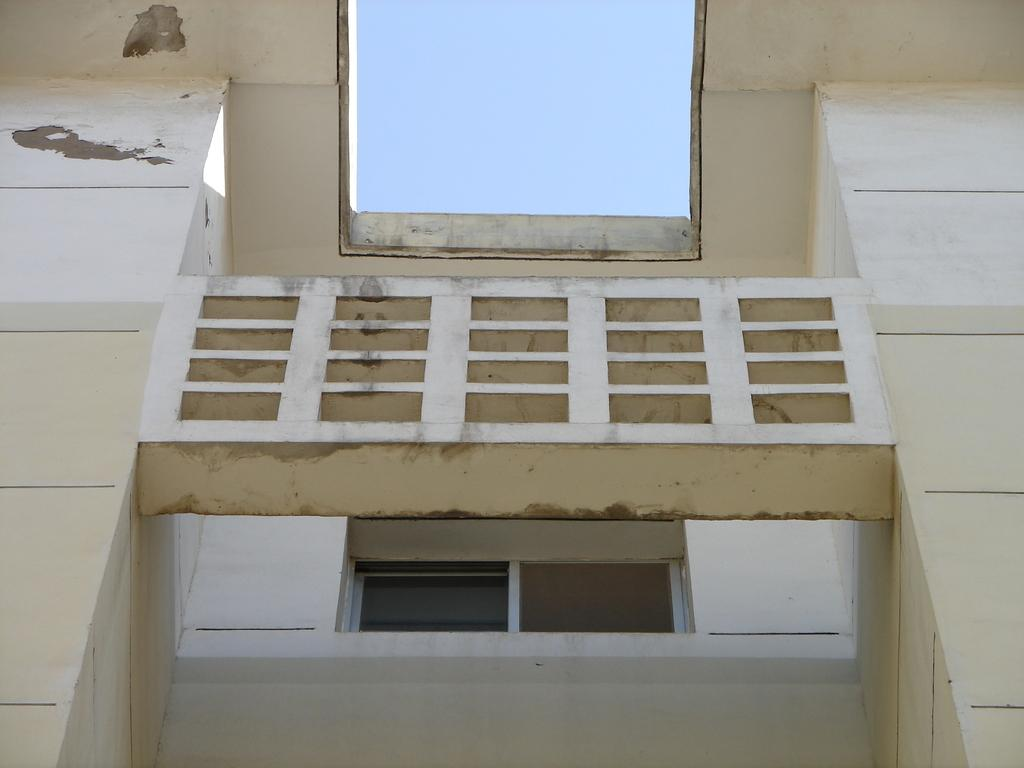What type of structure is present in the image? There is a building in the image. What feature can be observed on the building? The building has glass windows. What is visible at the top of the image? The sky is visible at the top of the image. How many eggs are on the roof of the building in the image? There are no eggs visible on the roof of the building in the image. 